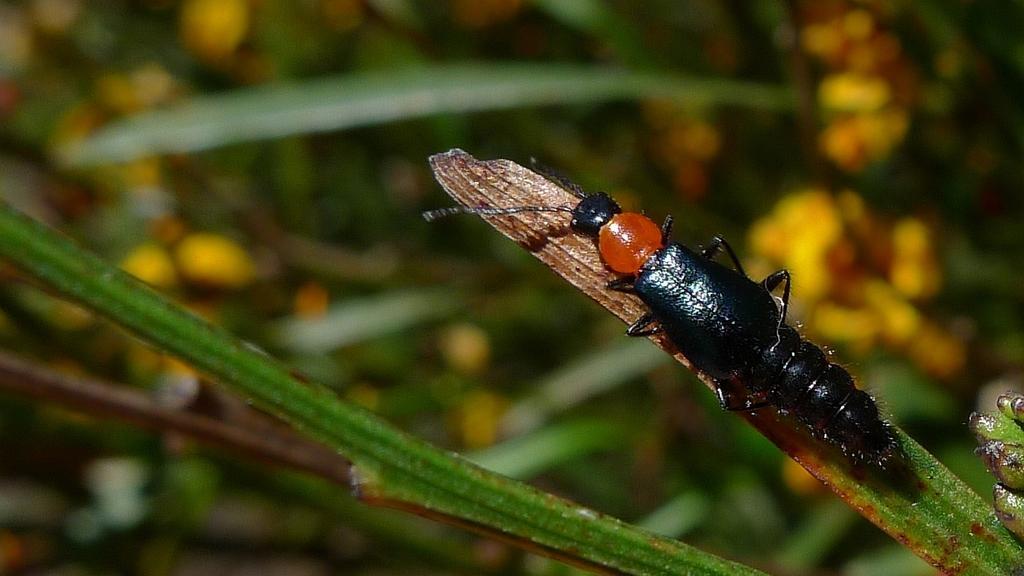Can you describe this image briefly? In this picture we can see an insect on a leaf and in the background we can see leaves, flowers and it is blurry. 